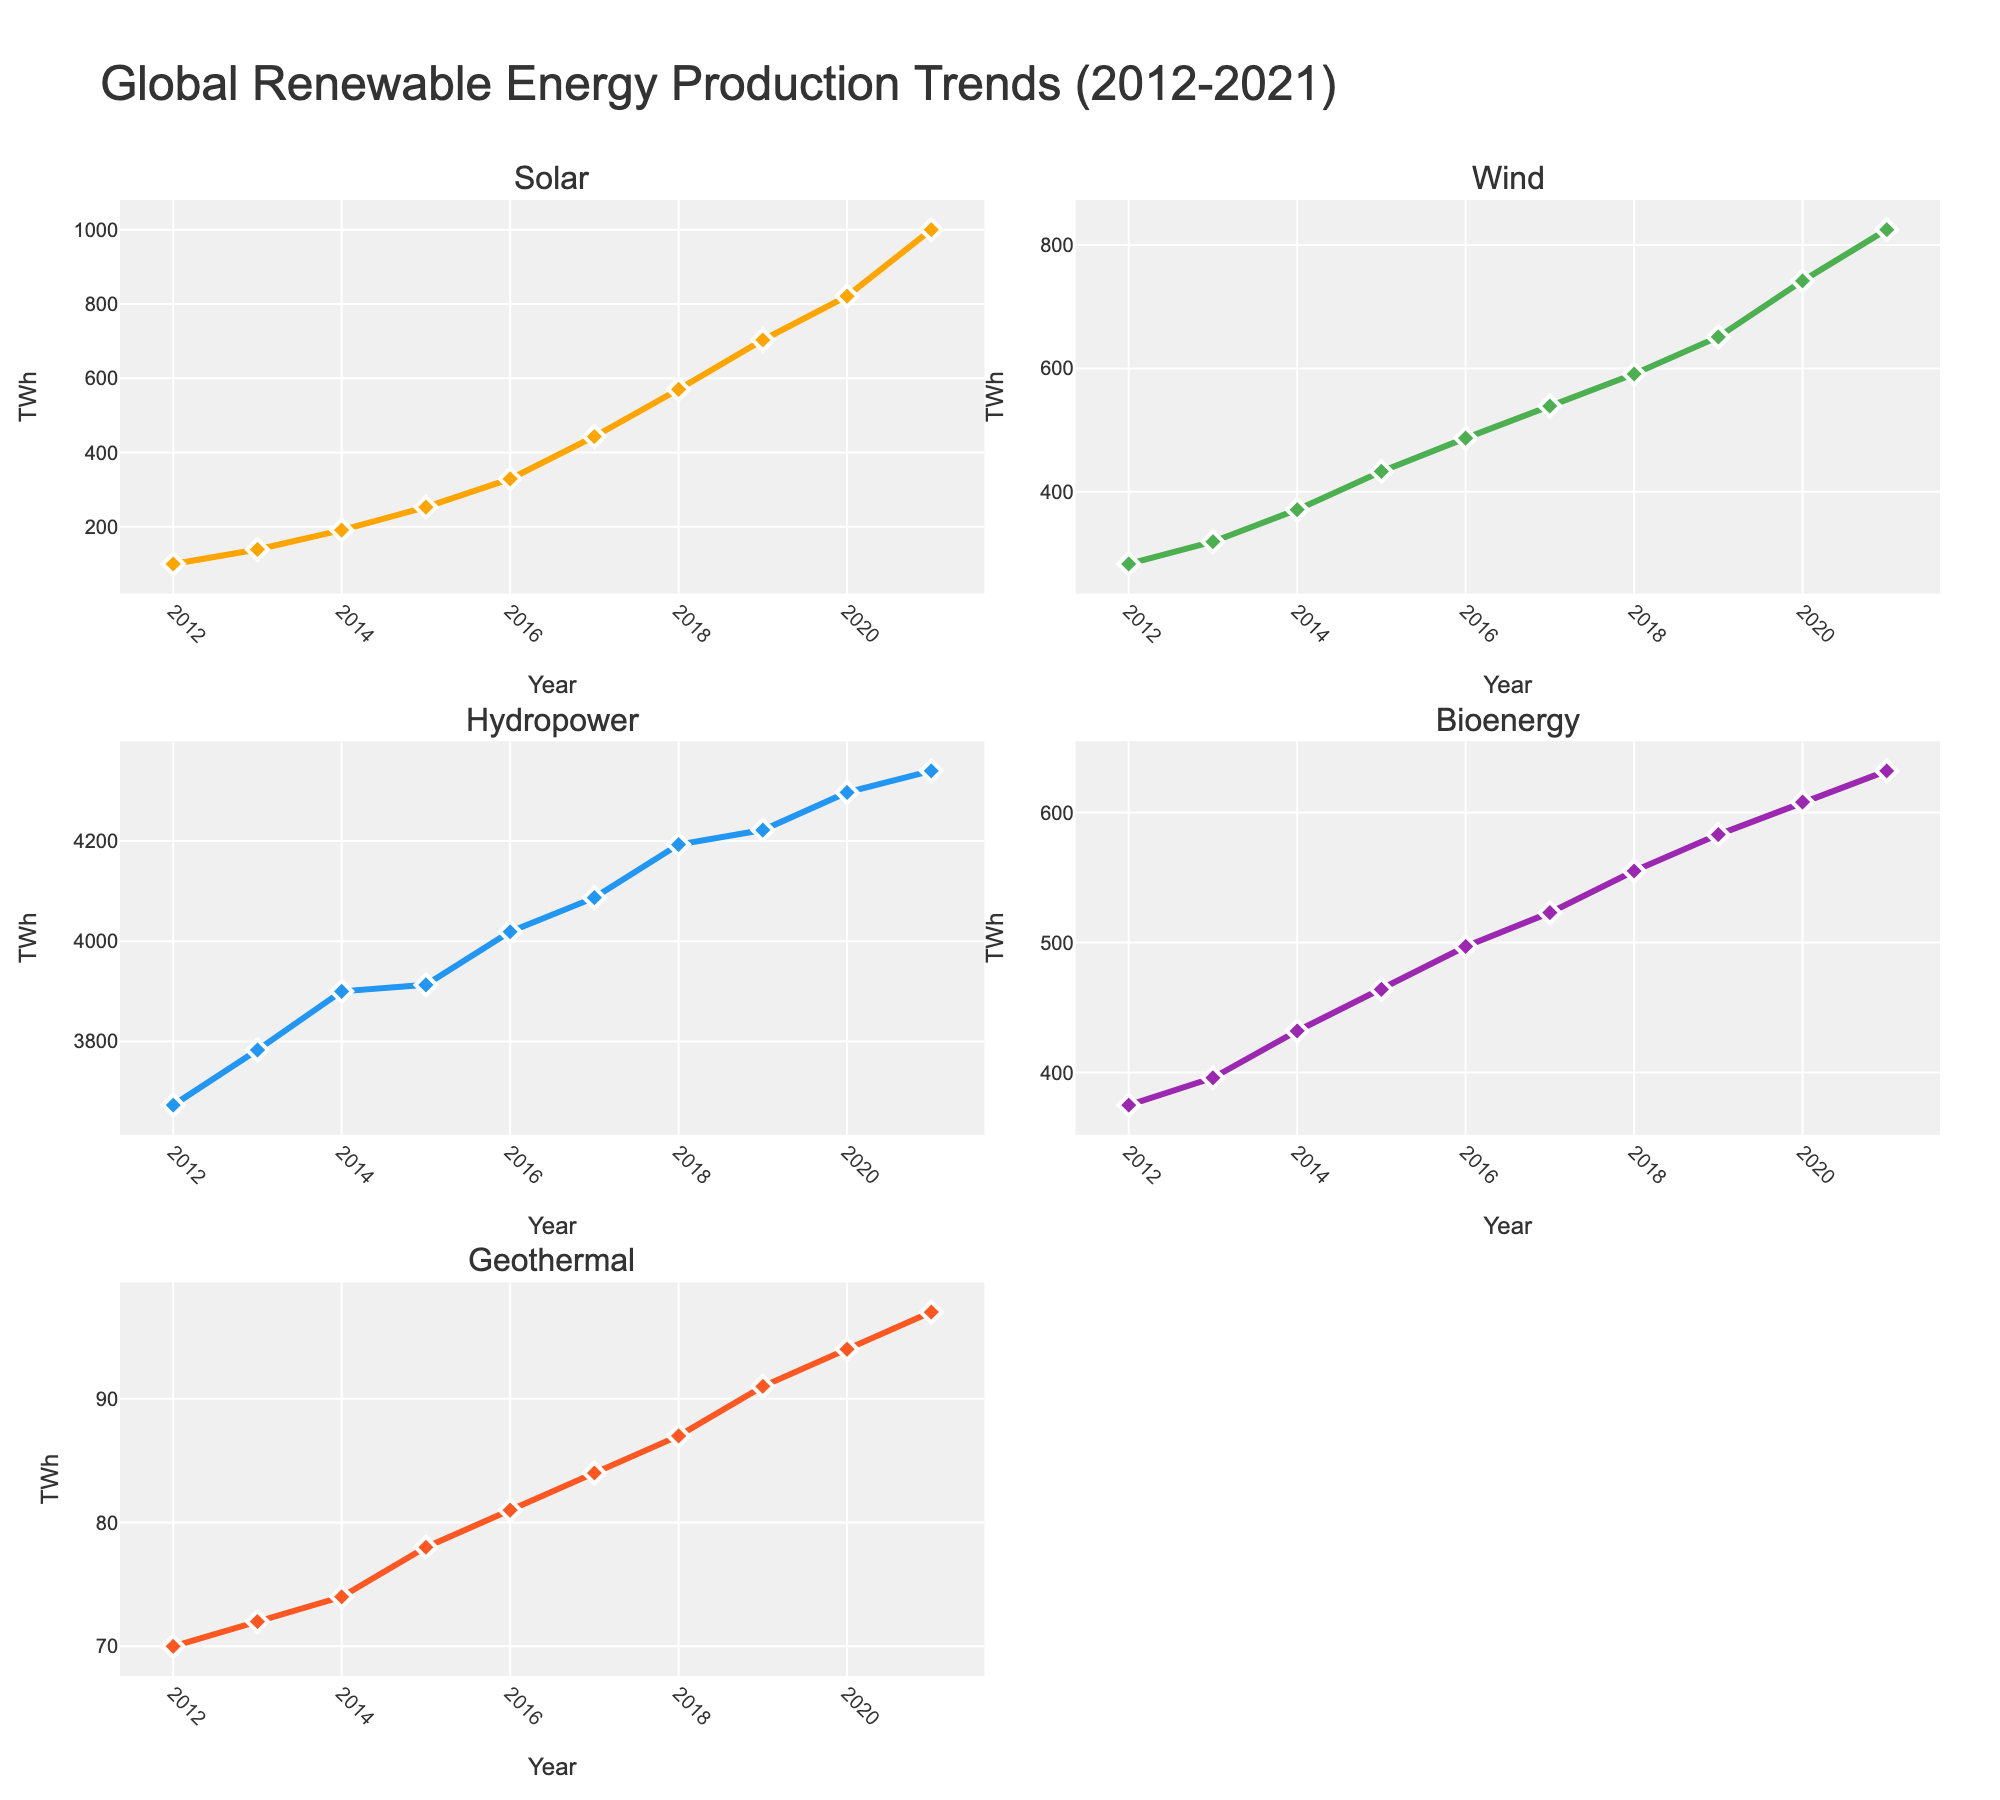How many renewable energy sources are shown in the figure? There are five subplots, each representing a different renewable energy source.
Answer: Five (Solar, Wind, Hydropower, Bioenergy, Geothermal) What is the title of the figure? The title is located at the top center of the figure.
Answer: Global Renewable Energy Production Trends (2012-2021) Which renewable energy source experienced the largest increase in production between 2012 and 2021? By analyzing the slopes of the lines in each subplot, it's clear that the solar energy subplot shows the steepest increase.
Answer: Solar What was the production of wind energy in 2015? Locate "Wind" subplot and find the data point for the year 2015. The y-axis value is approximately 433 TWh.
Answer: 433 TWh Compare the production of hydropower in 2012 and 2021. Did it increase, decrease, or remain the same? Look at the "Hydropower" subplot and compare the y-axis values for the years 2012 and 2021. It increased from 3673 TWh to 4340 TWh.
Answer: Increased What's the average annual production of bioenergy over the decade? Sum the bioenergy values from 2012 to 2021 and then divide by the number of years (10): (375+396+432+464+497+523+555+583+608+632)/10 = 506.5 TWh.
Answer: 506.5 TWh Which energy source had the least amount of production throughout the decade? Observe all the subplots and identify the one with the lowest y-axis values overall, which is the "Geothermal" subplot.
Answer: Geothermal During which year did solar energy production surpass 500 TWh? In the "Solar" subplot, find the point where the line exceeds 500 TWh, which occurs in the year 2018.
Answer: 2018 What is the approximate difference in wind energy production between 2012 and 2021? In the "Wind" subplot, subtract the y-axis value for 2012 (283 TWh) from that of 2021 (825 TWh): 825 - 283 = 542 TWh.
Answer: 542 TWh Rank the energy sources based on their production in 2021 from highest to lowest. Look at the y-axis values for 2021 in each subplot: Hydropower (4340 TWh), Wind (825 TWh), Solar (1000 TWh), Bioenergy (632 TWh), Geothermal (97 TWh).
Answer: Hydropower > Solar > Wind > Bioenergy > Geothermal 